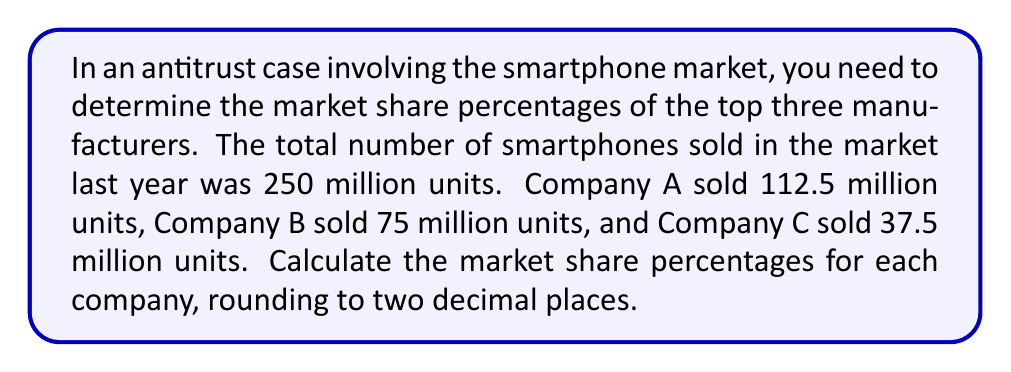Show me your answer to this math problem. To calculate the market share percentages, we need to divide each company's sales by the total market sales and multiply by 100. Let's break it down step-by-step:

1. Total market sales: 250 million units

2. Company A:
   $\text{Market Share}_A = \frac{\text{Company A Sales}}{\text{Total Market Sales}} \times 100\%$
   $$ \frac{112.5}{250} \times 100\% = 0.45 \times 100\% = 45\% $$

3. Company B:
   $\text{Market Share}_B = \frac{\text{Company B Sales}}{\text{Total Market Sales}} \times 100\%$
   $$ \frac{75}{250} \times 100\% = 0.30 \times 100\% = 30\% $$

4. Company C:
   $\text{Market Share}_C = \frac{\text{Company C Sales}}{\text{Total Market Sales}} \times 100\%$
   $$ \frac{37.5}{250} \times 100\% = 0.15 \times 100\% = 15\% $$

5. Verification:
   Sum of market shares: $45\% + 30\% + 15\% = 90\%$
   This leaves 10% for other smaller manufacturers, which is consistent with the given information.
Answer: Company A: 45.00%
Company B: 30.00%
Company C: 15.00% 